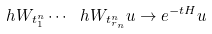Convert formula to latex. <formula><loc_0><loc_0><loc_500><loc_500>\ h W _ { t _ { 1 } ^ { n } } \cdots \ h W _ { t _ { r _ { n } } ^ { n } } u \rightarrow e ^ { - t H } u</formula> 